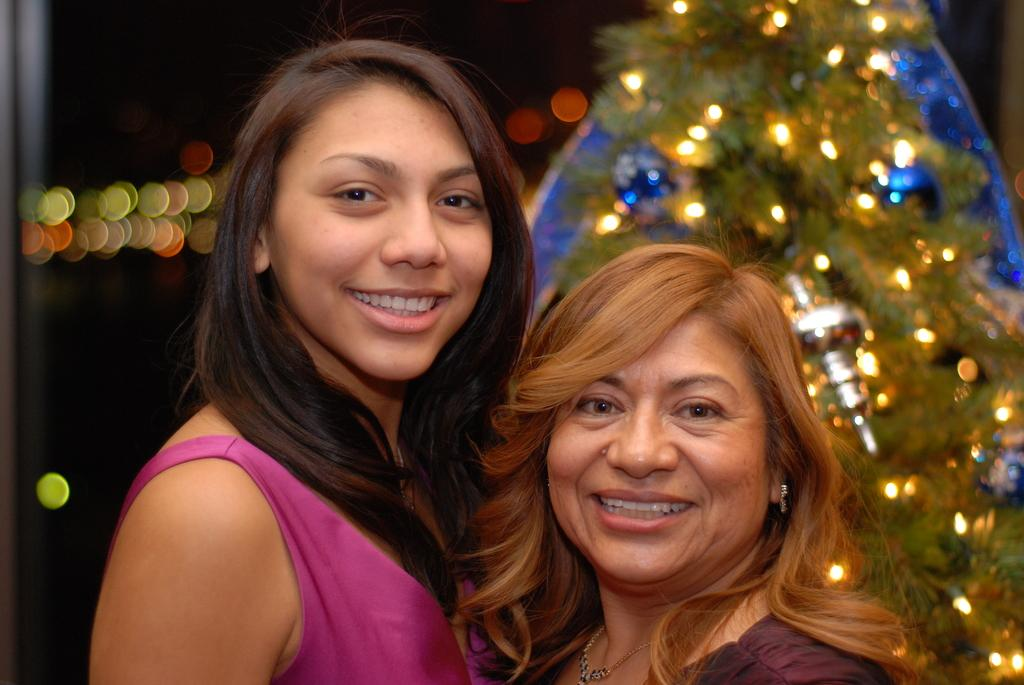How many people are in the image? There are two women in the image. What are the women doing in the image? The women are standing and smiling. What can be seen in the background of the image? There is a tree in the image. What type of lighting is present in the image? There are lighting elements in the image. What type of apparel is the letter wearing in the image? There is no letter present in the image, and therefore no apparel can be attributed to it. 